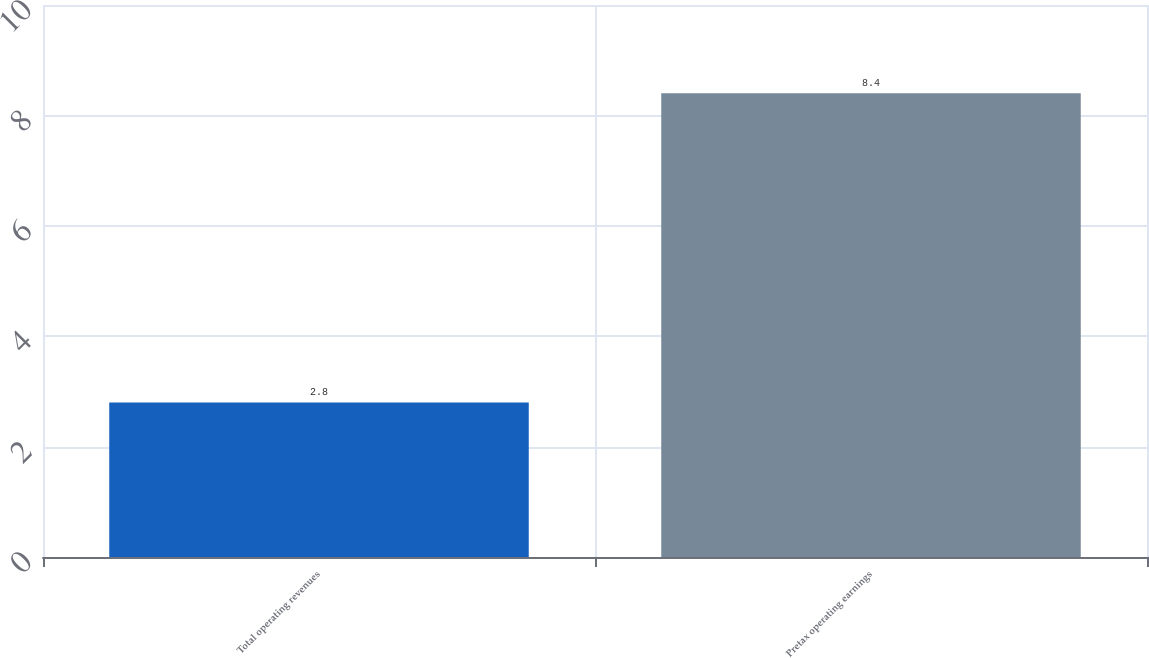<chart> <loc_0><loc_0><loc_500><loc_500><bar_chart><fcel>Total operating revenues<fcel>Pretax operating earnings<nl><fcel>2.8<fcel>8.4<nl></chart> 